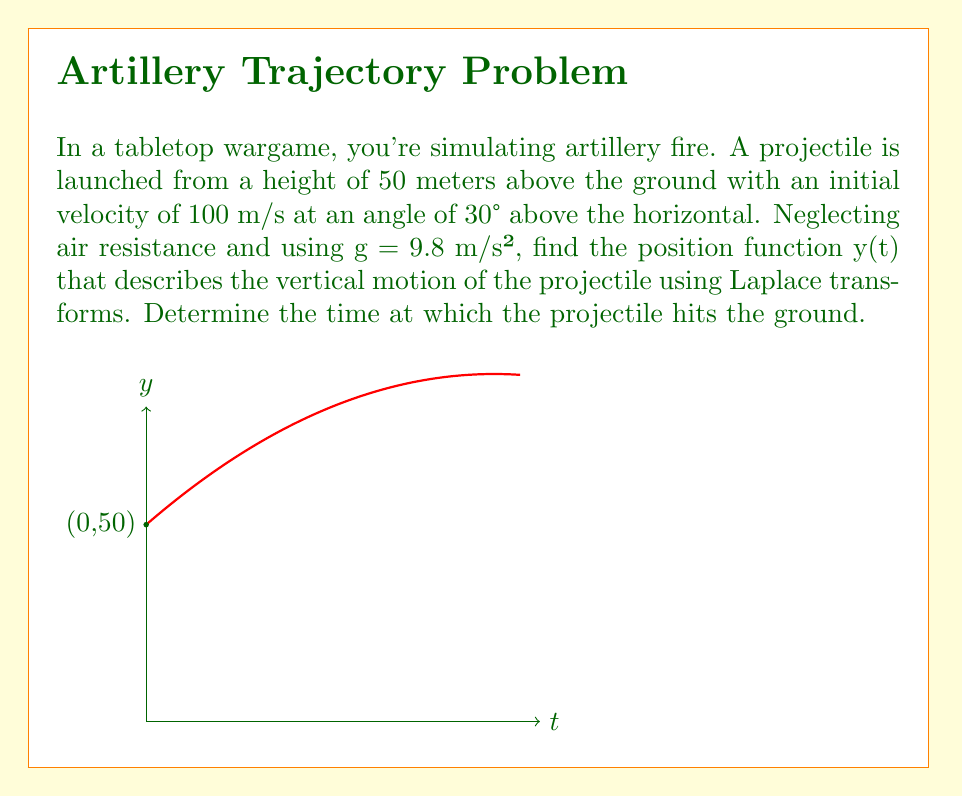Can you solve this math problem? Let's solve this step-by-step using Laplace transforms:

1) The differential equation for vertical motion is:
   $$\frac{d^2y}{dt^2} = -g$$

2) Initial conditions:
   $y(0) = 50$ (initial height)
   $\frac{dy}{dt}(0) = 100 \sin(30°) = 50$ (initial vertical velocity)

3) Take the Laplace transform of both sides:
   $$\mathcal{L}\{\frac{d^2y}{dt^2}\} = \mathcal{L}\{-g\}$$
   $$s^2Y(s) - sy(0) - y'(0) = -\frac{g}{s}$$

4) Substitute the initial conditions and g = 9.8:
   $$s^2Y(s) - 50s - 50 = -\frac{9.8}{s}$$

5) Solve for Y(s):
   $$Y(s) = \frac{50s + 50}{s^2} + \frac{9.8}{s^3}$$

6) Take the inverse Laplace transform:
   $$y(t) = 50 + 50t - 4.9t^2$$

7) To find when the projectile hits the ground, set y(t) = 0 and solve:
   $$0 = 50 + 50t - 4.9t^2$$
   $$4.9t^2 - 50t - 50 = 0$$

8) Using the quadratic formula:
   $$t = \frac{50 \pm \sqrt{2500 + 980}}{9.8} \approx 11.56 \text{ or } -0.88$$

9) We discard the negative solution, so the projectile hits the ground at t ≈ 11.56 seconds.
Answer: $y(t) = 50 + 50t - 4.9t^2$; Ground impact at t ≈ 11.56 s 